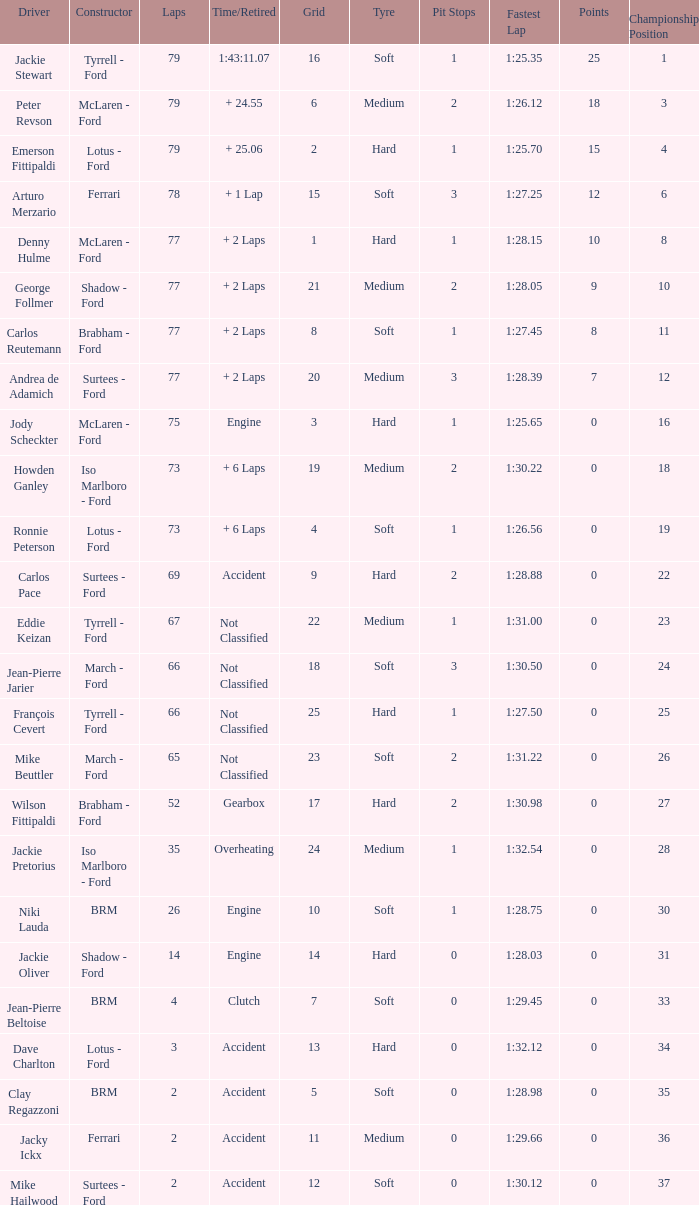How much time is required for less than 35 laps and less than 10 grids? Clutch, Accident. 